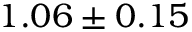<formula> <loc_0><loc_0><loc_500><loc_500>1 . 0 6 \pm 0 . 1 5</formula> 